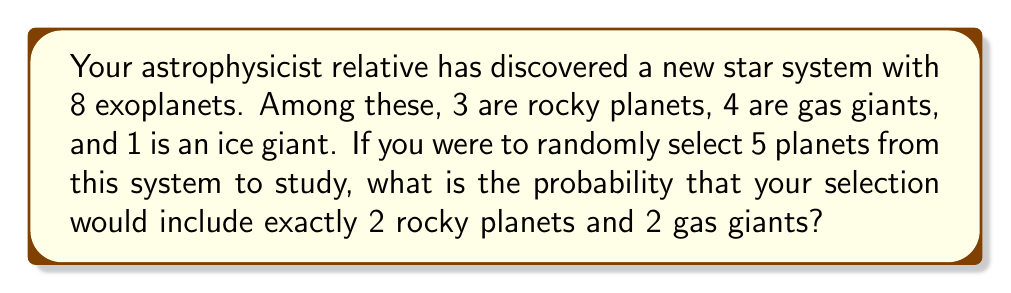Can you solve this math problem? Let's approach this step-by-step using the concept of combinations:

1) First, we need to choose 2 rocky planets out of 3:
   $${3 \choose 2} = \frac{3!}{2!(3-2)!} = 3$$

2) Then, we need to choose 2 gas giants out of 4:
   $${4 \choose 2} = \frac{4!}{2!(4-2)!} = 6$$

3) Finally, we need to choose 1 planet from the remaining 3 planets (1 rocky, 2 gas giants, and 1 ice giant):
   $${3 \choose 1} = 3$$

4) The total number of ways to select these specific combinations is:
   $$3 \times 6 \times 3 = 54$$

5) Now, we need to calculate the total number of ways to select any 5 planets out of 8:
   $${8 \choose 5} = \frac{8!}{5!(8-5)!} = 56$$

6) The probability is then:
   $$P(\text{2 rocky, 2 gas, 1 other}) = \frac{\text{favorable outcomes}}{\text{total outcomes}} = \frac{54}{56} = \frac{27}{28}$$

Therefore, the probability of selecting exactly 2 rocky planets and 2 gas giants when randomly choosing 5 out of the 8 exoplanets is $\frac{27}{28}$.
Answer: $\frac{27}{28}$ or approximately 0.9643 